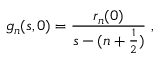Convert formula to latex. <formula><loc_0><loc_0><loc_500><loc_500>g _ { n } ( s , 0 ) = \frac { r _ { n } ( 0 ) } { s - ( n + \frac { 1 } { 2 } ) } \ ,</formula> 